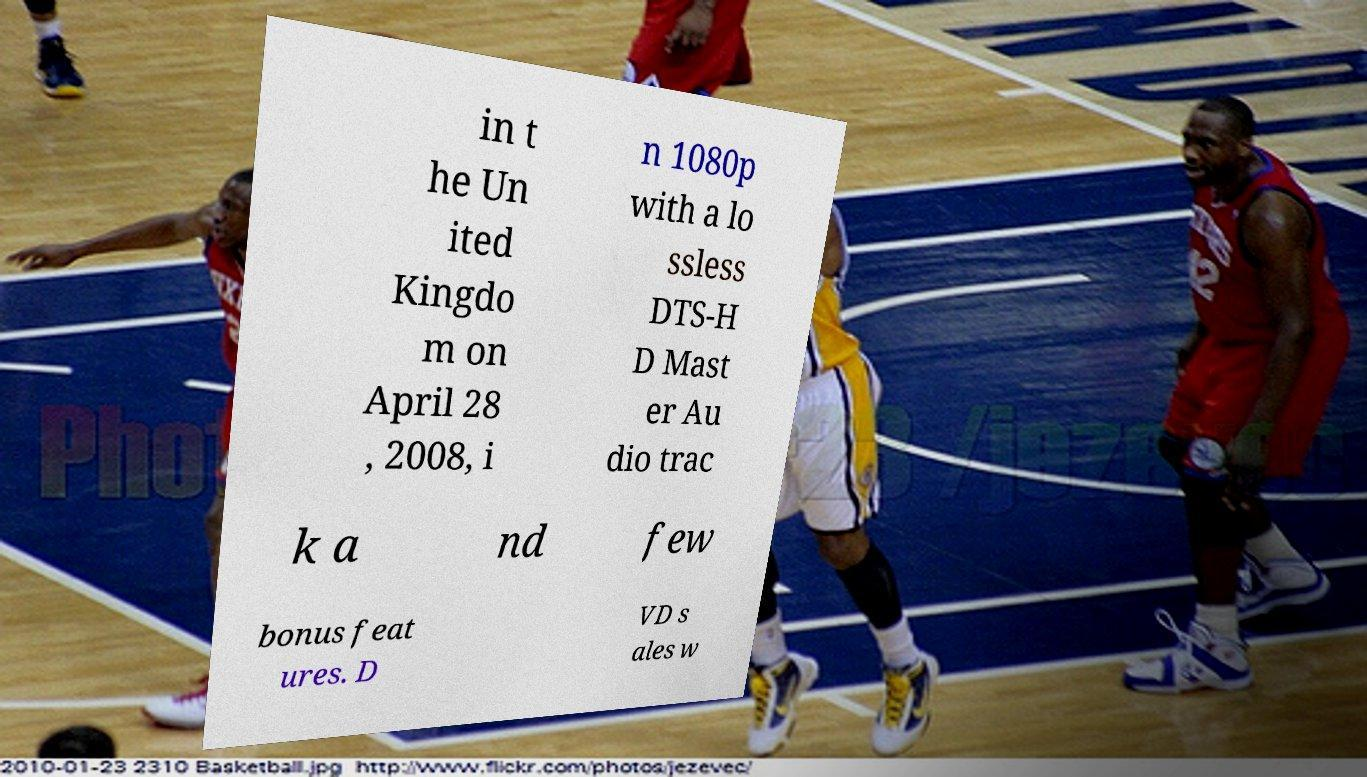I need the written content from this picture converted into text. Can you do that? in t he Un ited Kingdo m on April 28 , 2008, i n 1080p with a lo ssless DTS-H D Mast er Au dio trac k a nd few bonus feat ures. D VD s ales w 